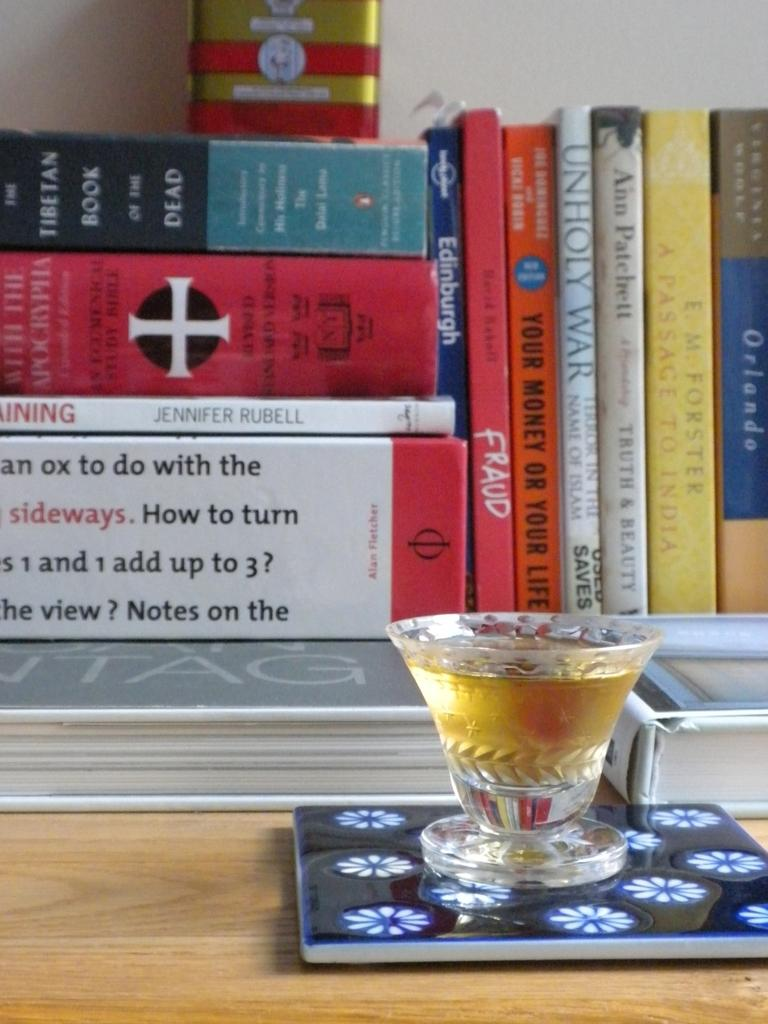What is the main subject of the image? The main subject of the image is a bunch of books. How many books are visible in the image? There are many books in the image. What is the location of the books in the image? The books are on a table in the image. Is there any other object visible on the table? Yes, there is a glass with some liquid on the table. What type of fruit is being sliced in the image? There is no fruit present in the image, and therefore no slicing of fruit can be observed. 